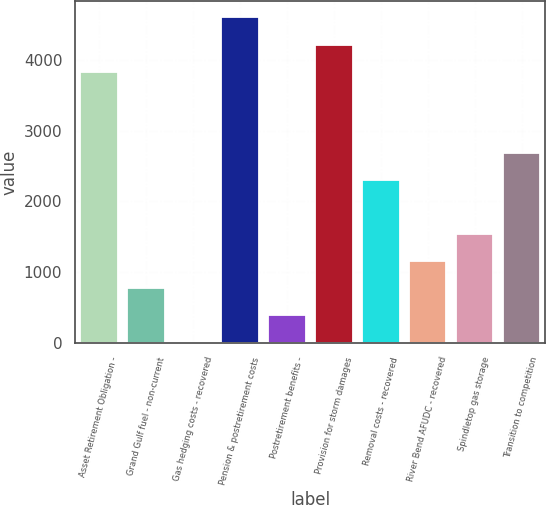Convert chart to OTSL. <chart><loc_0><loc_0><loc_500><loc_500><bar_chart><fcel>Asset Retirement Obligation -<fcel>Grand Gulf fuel - non-current<fcel>Gas hedging costs - recovered<fcel>Pension & postretirement costs<fcel>Postretirement benefits -<fcel>Provision for storm damages<fcel>Removal costs - recovered<fcel>River Bend AFUDC - recovered<fcel>Spindletop gas storage<fcel>Transition to competition<nl><fcel>3838.2<fcel>769.16<fcel>1.9<fcel>4605.46<fcel>385.53<fcel>4221.83<fcel>2303.68<fcel>1152.79<fcel>1536.42<fcel>2687.31<nl></chart> 